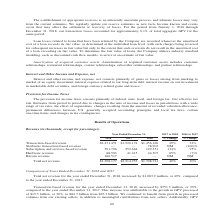According to Square's financial document, What was the cause of the increase in transaction-based revenue from 2017 to 2018? the growth in GPV processed of $19.3 billion, or 30%, to $84.7 billion from $65.3 billion. The document states: "ember 31, 2017. This increase was attributable to the growth in GPV processed of $19.3 billion, or 30%, to $84.7 billion from $65.3 billion. We contin..." Also, What was the cause of the increase in Subscription and services-based revenue from 2017 to 2018? Based on the financial document, the answer is Instant Deposit, Caviar, Cash Card, and Square Capital, as well as acquisitions completed in the second quarter. Also, How much did bitcoin revenue increase from 2017 to 2018? Based on the financial document, the answer is $166.5 million. Additionally, Which period has the larger percentage change in total net revenue? According to the financial document, 2017 to 2018. The relevant text states: "Year Ended December 31, 2017 to 2018 2016 to 2017..." Also, can you calculate: What is the percentage amount of Bitcoin revenue among the total net revenue in 2018? Based on the calculation: 166,517 / 3,298,177 , the result is 5.05 (percentage). This is based on the information: "Total net revenue $3,298,177 $2,214,253 $1,708,721 49% 30% nue 68,503 41,415 44,307 65% (7)% Bitcoin revenue 166,517 — — NM NM..." The key data points involved are: 166,517, 3,298,177. Also, can you calculate: What is the average hardware revenue from 2016 to 2018? To answer this question, I need to perform calculations using the financial data. The calculation is: (44,307 + 41,415 + 68,503) / 3 , which equals 51408.33 (in thousands). This is based on the information: "591,706 252,664 129,351 134% 95% Hardware revenue 68,503 41,415 44,307 65% (7)% Bitcoin revenue 166,517 — — NM NM 4 129,351 134% 95% Hardware revenue 68,503 41,415 44,307 65% (7)% Bitcoin revenue 166,..." The key data points involved are: 41,415, 44,307, 68,503. 